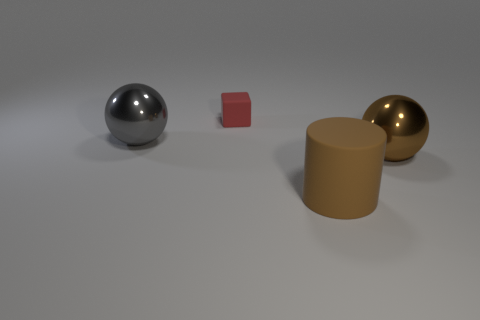Add 3 gray metallic balls. How many objects exist? 7 Subtract all blocks. How many objects are left? 3 Subtract 0 green cylinders. How many objects are left? 4 Subtract all big metal balls. Subtract all brown spheres. How many objects are left? 1 Add 1 big objects. How many big objects are left? 4 Add 4 small yellow metallic spheres. How many small yellow metallic spheres exist? 4 